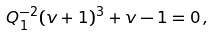Convert formula to latex. <formula><loc_0><loc_0><loc_500><loc_500>Q _ { 1 } ^ { - 2 } ( v + 1 ) ^ { 3 } + v - 1 = 0 \, ,</formula> 